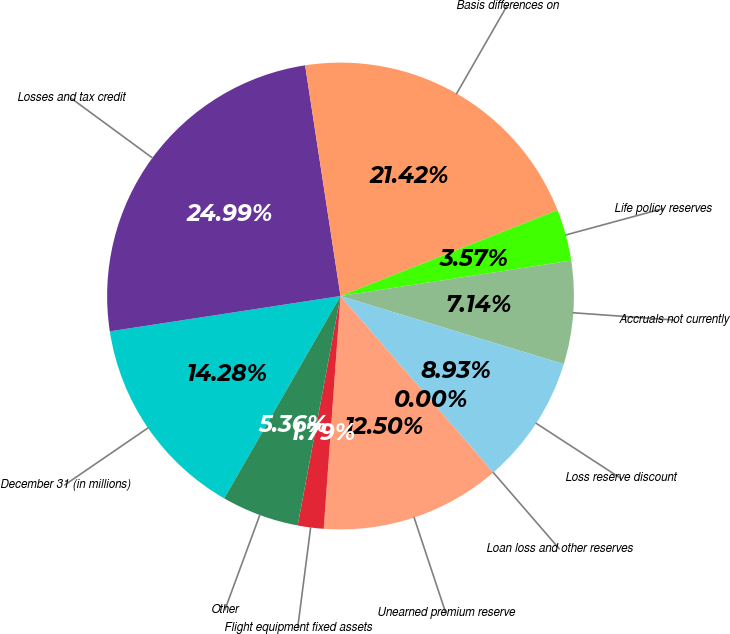Convert chart. <chart><loc_0><loc_0><loc_500><loc_500><pie_chart><fcel>December 31 (in millions)<fcel>Losses and tax credit<fcel>Basis differences on<fcel>Life policy reserves<fcel>Accruals not currently<fcel>Loss reserve discount<fcel>Loan loss and other reserves<fcel>Unearned premium reserve<fcel>Flight equipment fixed assets<fcel>Other<nl><fcel>14.28%<fcel>24.99%<fcel>21.42%<fcel>3.57%<fcel>7.14%<fcel>8.93%<fcel>0.0%<fcel>12.5%<fcel>1.79%<fcel>5.36%<nl></chart> 